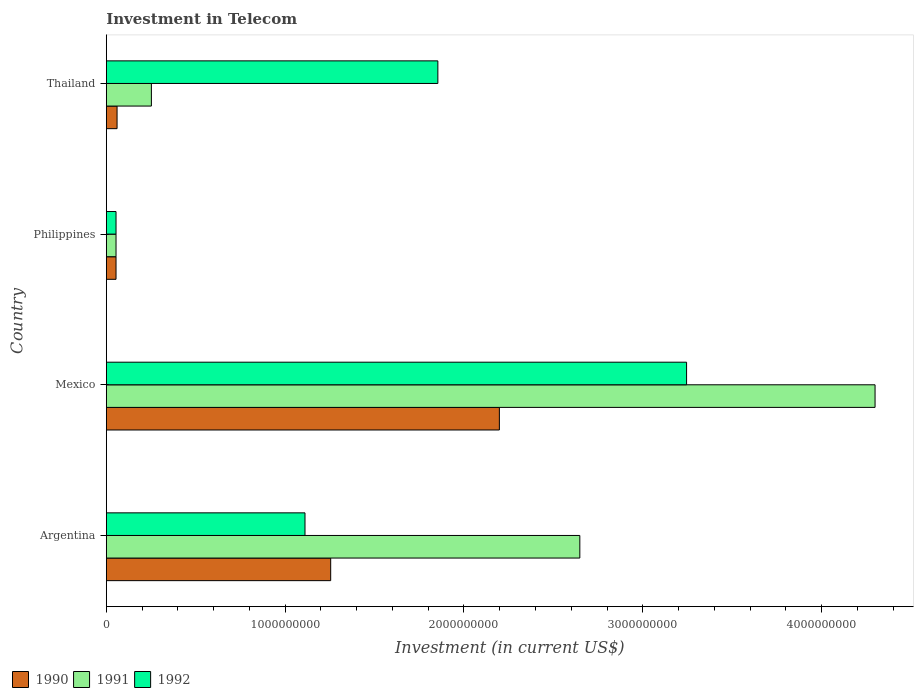How many different coloured bars are there?
Make the answer very short. 3. How many groups of bars are there?
Offer a very short reply. 4. What is the label of the 1st group of bars from the top?
Give a very brief answer. Thailand. In how many cases, is the number of bars for a given country not equal to the number of legend labels?
Keep it short and to the point. 0. What is the amount invested in telecom in 1991 in Argentina?
Your answer should be compact. 2.65e+09. Across all countries, what is the maximum amount invested in telecom in 1990?
Your answer should be compact. 2.20e+09. Across all countries, what is the minimum amount invested in telecom in 1990?
Your answer should be very brief. 5.42e+07. What is the total amount invested in telecom in 1990 in the graph?
Offer a terse response. 3.57e+09. What is the difference between the amount invested in telecom in 1990 in Argentina and that in Thailand?
Offer a very short reply. 1.19e+09. What is the difference between the amount invested in telecom in 1992 in Thailand and the amount invested in telecom in 1990 in Philippines?
Provide a short and direct response. 1.80e+09. What is the average amount invested in telecom in 1990 per country?
Your response must be concise. 8.92e+08. What is the difference between the amount invested in telecom in 1991 and amount invested in telecom in 1990 in Mexico?
Keep it short and to the point. 2.10e+09. In how many countries, is the amount invested in telecom in 1990 greater than 1600000000 US$?
Provide a succinct answer. 1. What is the ratio of the amount invested in telecom in 1990 in Argentina to that in Thailand?
Keep it short and to the point. 20.91. Is the difference between the amount invested in telecom in 1991 in Argentina and Philippines greater than the difference between the amount invested in telecom in 1990 in Argentina and Philippines?
Offer a very short reply. Yes. What is the difference between the highest and the second highest amount invested in telecom in 1991?
Provide a succinct answer. 1.65e+09. What is the difference between the highest and the lowest amount invested in telecom in 1992?
Offer a terse response. 3.19e+09. Is the sum of the amount invested in telecom in 1991 in Mexico and Thailand greater than the maximum amount invested in telecom in 1990 across all countries?
Give a very brief answer. Yes. What does the 1st bar from the bottom in Thailand represents?
Keep it short and to the point. 1990. How many bars are there?
Make the answer very short. 12. How many countries are there in the graph?
Provide a short and direct response. 4. Are the values on the major ticks of X-axis written in scientific E-notation?
Offer a very short reply. No. Does the graph contain grids?
Offer a terse response. No. Where does the legend appear in the graph?
Give a very brief answer. Bottom left. How many legend labels are there?
Your response must be concise. 3. What is the title of the graph?
Ensure brevity in your answer.  Investment in Telecom. Does "1967" appear as one of the legend labels in the graph?
Your response must be concise. No. What is the label or title of the X-axis?
Offer a terse response. Investment (in current US$). What is the Investment (in current US$) of 1990 in Argentina?
Make the answer very short. 1.25e+09. What is the Investment (in current US$) in 1991 in Argentina?
Offer a terse response. 2.65e+09. What is the Investment (in current US$) in 1992 in Argentina?
Give a very brief answer. 1.11e+09. What is the Investment (in current US$) in 1990 in Mexico?
Your answer should be compact. 2.20e+09. What is the Investment (in current US$) in 1991 in Mexico?
Ensure brevity in your answer.  4.30e+09. What is the Investment (in current US$) in 1992 in Mexico?
Make the answer very short. 3.24e+09. What is the Investment (in current US$) in 1990 in Philippines?
Offer a very short reply. 5.42e+07. What is the Investment (in current US$) in 1991 in Philippines?
Provide a short and direct response. 5.42e+07. What is the Investment (in current US$) in 1992 in Philippines?
Offer a very short reply. 5.42e+07. What is the Investment (in current US$) in 1990 in Thailand?
Keep it short and to the point. 6.00e+07. What is the Investment (in current US$) of 1991 in Thailand?
Offer a terse response. 2.52e+08. What is the Investment (in current US$) of 1992 in Thailand?
Your answer should be very brief. 1.85e+09. Across all countries, what is the maximum Investment (in current US$) in 1990?
Keep it short and to the point. 2.20e+09. Across all countries, what is the maximum Investment (in current US$) in 1991?
Your response must be concise. 4.30e+09. Across all countries, what is the maximum Investment (in current US$) in 1992?
Your answer should be very brief. 3.24e+09. Across all countries, what is the minimum Investment (in current US$) in 1990?
Your response must be concise. 5.42e+07. Across all countries, what is the minimum Investment (in current US$) in 1991?
Keep it short and to the point. 5.42e+07. Across all countries, what is the minimum Investment (in current US$) in 1992?
Your response must be concise. 5.42e+07. What is the total Investment (in current US$) of 1990 in the graph?
Your response must be concise. 3.57e+09. What is the total Investment (in current US$) of 1991 in the graph?
Offer a terse response. 7.25e+09. What is the total Investment (in current US$) in 1992 in the graph?
Your answer should be compact. 6.26e+09. What is the difference between the Investment (in current US$) in 1990 in Argentina and that in Mexico?
Offer a terse response. -9.43e+08. What is the difference between the Investment (in current US$) of 1991 in Argentina and that in Mexico?
Keep it short and to the point. -1.65e+09. What is the difference between the Investment (in current US$) of 1992 in Argentina and that in Mexico?
Your answer should be compact. -2.13e+09. What is the difference between the Investment (in current US$) in 1990 in Argentina and that in Philippines?
Your answer should be very brief. 1.20e+09. What is the difference between the Investment (in current US$) of 1991 in Argentina and that in Philippines?
Your answer should be compact. 2.59e+09. What is the difference between the Investment (in current US$) in 1992 in Argentina and that in Philippines?
Ensure brevity in your answer.  1.06e+09. What is the difference between the Investment (in current US$) in 1990 in Argentina and that in Thailand?
Offer a terse response. 1.19e+09. What is the difference between the Investment (in current US$) of 1991 in Argentina and that in Thailand?
Make the answer very short. 2.40e+09. What is the difference between the Investment (in current US$) of 1992 in Argentina and that in Thailand?
Make the answer very short. -7.43e+08. What is the difference between the Investment (in current US$) in 1990 in Mexico and that in Philippines?
Offer a very short reply. 2.14e+09. What is the difference between the Investment (in current US$) of 1991 in Mexico and that in Philippines?
Give a very brief answer. 4.24e+09. What is the difference between the Investment (in current US$) in 1992 in Mexico and that in Philippines?
Provide a short and direct response. 3.19e+09. What is the difference between the Investment (in current US$) of 1990 in Mexico and that in Thailand?
Provide a short and direct response. 2.14e+09. What is the difference between the Investment (in current US$) in 1991 in Mexico and that in Thailand?
Keep it short and to the point. 4.05e+09. What is the difference between the Investment (in current US$) of 1992 in Mexico and that in Thailand?
Your answer should be compact. 1.39e+09. What is the difference between the Investment (in current US$) of 1990 in Philippines and that in Thailand?
Ensure brevity in your answer.  -5.80e+06. What is the difference between the Investment (in current US$) in 1991 in Philippines and that in Thailand?
Provide a short and direct response. -1.98e+08. What is the difference between the Investment (in current US$) in 1992 in Philippines and that in Thailand?
Offer a very short reply. -1.80e+09. What is the difference between the Investment (in current US$) in 1990 in Argentina and the Investment (in current US$) in 1991 in Mexico?
Offer a terse response. -3.04e+09. What is the difference between the Investment (in current US$) of 1990 in Argentina and the Investment (in current US$) of 1992 in Mexico?
Ensure brevity in your answer.  -1.99e+09. What is the difference between the Investment (in current US$) in 1991 in Argentina and the Investment (in current US$) in 1992 in Mexico?
Give a very brief answer. -5.97e+08. What is the difference between the Investment (in current US$) of 1990 in Argentina and the Investment (in current US$) of 1991 in Philippines?
Your answer should be compact. 1.20e+09. What is the difference between the Investment (in current US$) of 1990 in Argentina and the Investment (in current US$) of 1992 in Philippines?
Your answer should be compact. 1.20e+09. What is the difference between the Investment (in current US$) of 1991 in Argentina and the Investment (in current US$) of 1992 in Philippines?
Ensure brevity in your answer.  2.59e+09. What is the difference between the Investment (in current US$) in 1990 in Argentina and the Investment (in current US$) in 1991 in Thailand?
Your response must be concise. 1.00e+09. What is the difference between the Investment (in current US$) of 1990 in Argentina and the Investment (in current US$) of 1992 in Thailand?
Give a very brief answer. -5.99e+08. What is the difference between the Investment (in current US$) in 1991 in Argentina and the Investment (in current US$) in 1992 in Thailand?
Keep it short and to the point. 7.94e+08. What is the difference between the Investment (in current US$) in 1990 in Mexico and the Investment (in current US$) in 1991 in Philippines?
Make the answer very short. 2.14e+09. What is the difference between the Investment (in current US$) of 1990 in Mexico and the Investment (in current US$) of 1992 in Philippines?
Offer a terse response. 2.14e+09. What is the difference between the Investment (in current US$) of 1991 in Mexico and the Investment (in current US$) of 1992 in Philippines?
Provide a short and direct response. 4.24e+09. What is the difference between the Investment (in current US$) of 1990 in Mexico and the Investment (in current US$) of 1991 in Thailand?
Make the answer very short. 1.95e+09. What is the difference between the Investment (in current US$) of 1990 in Mexico and the Investment (in current US$) of 1992 in Thailand?
Give a very brief answer. 3.44e+08. What is the difference between the Investment (in current US$) of 1991 in Mexico and the Investment (in current US$) of 1992 in Thailand?
Your response must be concise. 2.44e+09. What is the difference between the Investment (in current US$) of 1990 in Philippines and the Investment (in current US$) of 1991 in Thailand?
Keep it short and to the point. -1.98e+08. What is the difference between the Investment (in current US$) in 1990 in Philippines and the Investment (in current US$) in 1992 in Thailand?
Ensure brevity in your answer.  -1.80e+09. What is the difference between the Investment (in current US$) of 1991 in Philippines and the Investment (in current US$) of 1992 in Thailand?
Your response must be concise. -1.80e+09. What is the average Investment (in current US$) in 1990 per country?
Offer a very short reply. 8.92e+08. What is the average Investment (in current US$) of 1991 per country?
Give a very brief answer. 1.81e+09. What is the average Investment (in current US$) of 1992 per country?
Provide a succinct answer. 1.57e+09. What is the difference between the Investment (in current US$) of 1990 and Investment (in current US$) of 1991 in Argentina?
Offer a very short reply. -1.39e+09. What is the difference between the Investment (in current US$) in 1990 and Investment (in current US$) in 1992 in Argentina?
Your answer should be very brief. 1.44e+08. What is the difference between the Investment (in current US$) in 1991 and Investment (in current US$) in 1992 in Argentina?
Your answer should be very brief. 1.54e+09. What is the difference between the Investment (in current US$) of 1990 and Investment (in current US$) of 1991 in Mexico?
Your answer should be very brief. -2.10e+09. What is the difference between the Investment (in current US$) of 1990 and Investment (in current US$) of 1992 in Mexico?
Your response must be concise. -1.05e+09. What is the difference between the Investment (in current US$) of 1991 and Investment (in current US$) of 1992 in Mexico?
Keep it short and to the point. 1.05e+09. What is the difference between the Investment (in current US$) of 1990 and Investment (in current US$) of 1991 in Philippines?
Provide a short and direct response. 0. What is the difference between the Investment (in current US$) of 1990 and Investment (in current US$) of 1991 in Thailand?
Your answer should be very brief. -1.92e+08. What is the difference between the Investment (in current US$) in 1990 and Investment (in current US$) in 1992 in Thailand?
Provide a short and direct response. -1.79e+09. What is the difference between the Investment (in current US$) of 1991 and Investment (in current US$) of 1992 in Thailand?
Keep it short and to the point. -1.60e+09. What is the ratio of the Investment (in current US$) of 1990 in Argentina to that in Mexico?
Provide a succinct answer. 0.57. What is the ratio of the Investment (in current US$) in 1991 in Argentina to that in Mexico?
Provide a succinct answer. 0.62. What is the ratio of the Investment (in current US$) of 1992 in Argentina to that in Mexico?
Your answer should be compact. 0.34. What is the ratio of the Investment (in current US$) of 1990 in Argentina to that in Philippines?
Provide a short and direct response. 23.15. What is the ratio of the Investment (in current US$) of 1991 in Argentina to that in Philippines?
Ensure brevity in your answer.  48.86. What is the ratio of the Investment (in current US$) of 1992 in Argentina to that in Philippines?
Provide a succinct answer. 20.5. What is the ratio of the Investment (in current US$) of 1990 in Argentina to that in Thailand?
Offer a terse response. 20.91. What is the ratio of the Investment (in current US$) in 1991 in Argentina to that in Thailand?
Provide a succinct answer. 10.51. What is the ratio of the Investment (in current US$) of 1992 in Argentina to that in Thailand?
Provide a succinct answer. 0.6. What is the ratio of the Investment (in current US$) in 1990 in Mexico to that in Philippines?
Ensure brevity in your answer.  40.55. What is the ratio of the Investment (in current US$) of 1991 in Mexico to that in Philippines?
Offer a very short reply. 79.32. What is the ratio of the Investment (in current US$) in 1992 in Mexico to that in Philippines?
Keep it short and to the point. 59.87. What is the ratio of the Investment (in current US$) in 1990 in Mexico to that in Thailand?
Your answer should be compact. 36.63. What is the ratio of the Investment (in current US$) in 1991 in Mexico to that in Thailand?
Provide a short and direct response. 17.06. What is the ratio of the Investment (in current US$) of 1992 in Mexico to that in Thailand?
Provide a succinct answer. 1.75. What is the ratio of the Investment (in current US$) of 1990 in Philippines to that in Thailand?
Offer a very short reply. 0.9. What is the ratio of the Investment (in current US$) in 1991 in Philippines to that in Thailand?
Your answer should be compact. 0.22. What is the ratio of the Investment (in current US$) in 1992 in Philippines to that in Thailand?
Provide a succinct answer. 0.03. What is the difference between the highest and the second highest Investment (in current US$) in 1990?
Provide a succinct answer. 9.43e+08. What is the difference between the highest and the second highest Investment (in current US$) in 1991?
Offer a very short reply. 1.65e+09. What is the difference between the highest and the second highest Investment (in current US$) of 1992?
Offer a terse response. 1.39e+09. What is the difference between the highest and the lowest Investment (in current US$) in 1990?
Give a very brief answer. 2.14e+09. What is the difference between the highest and the lowest Investment (in current US$) of 1991?
Your answer should be very brief. 4.24e+09. What is the difference between the highest and the lowest Investment (in current US$) in 1992?
Provide a succinct answer. 3.19e+09. 